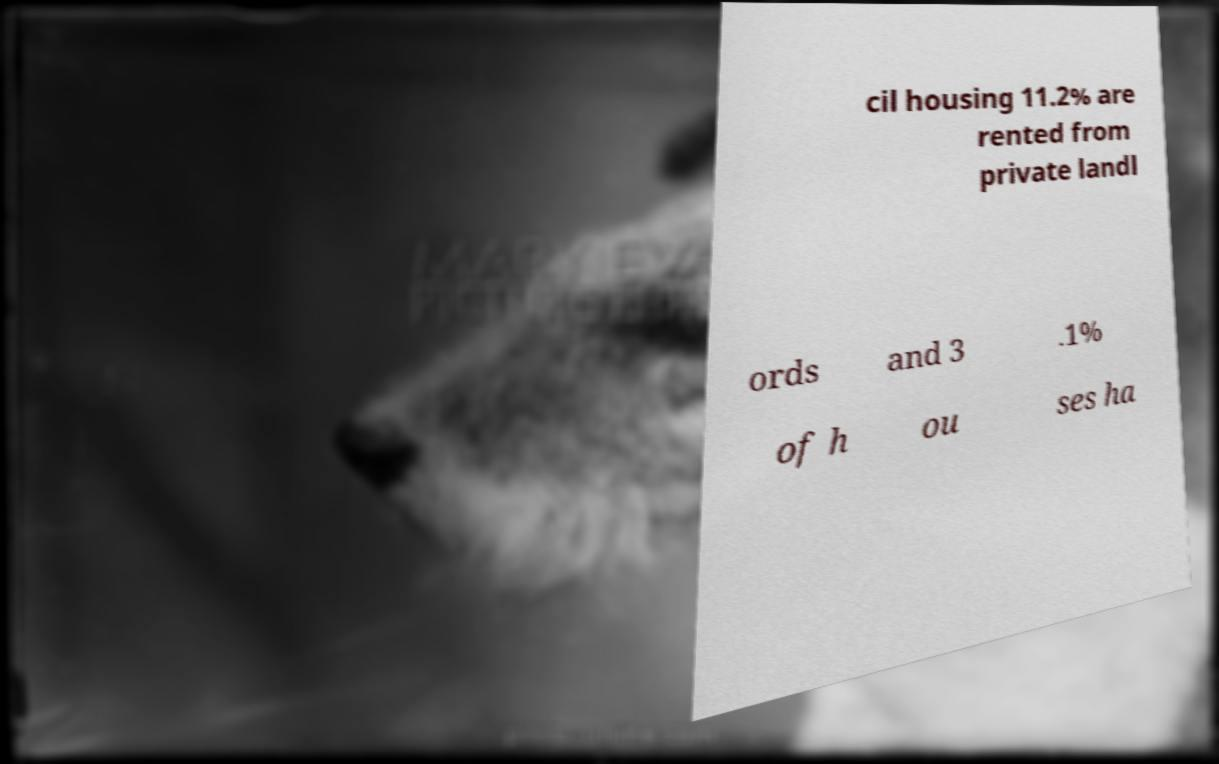Could you assist in decoding the text presented in this image and type it out clearly? cil housing 11.2% are rented from private landl ords and 3 .1% of h ou ses ha 